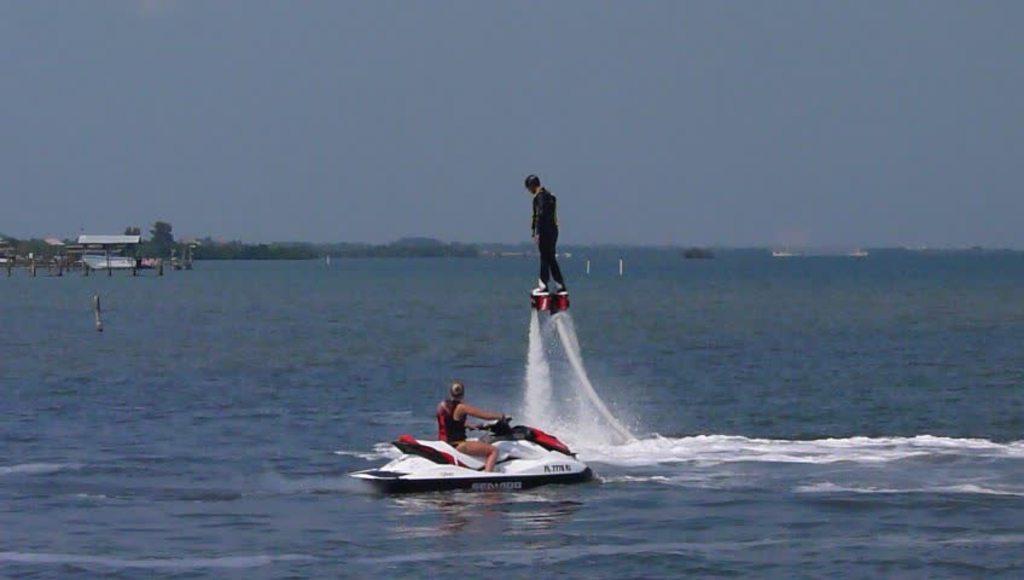Could you give a brief overview of what you see in this image? In the center of the image we can see one person flyboarding on water and he is wearing a helmet. And the other person is jet skiing on water. In the background we can see the sky, trees, poles, banners, water etc. 